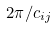Convert formula to latex. <formula><loc_0><loc_0><loc_500><loc_500>2 \pi / c _ { i j }</formula> 